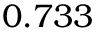Convert formula to latex. <formula><loc_0><loc_0><loc_500><loc_500>0 . 7 3 3</formula> 